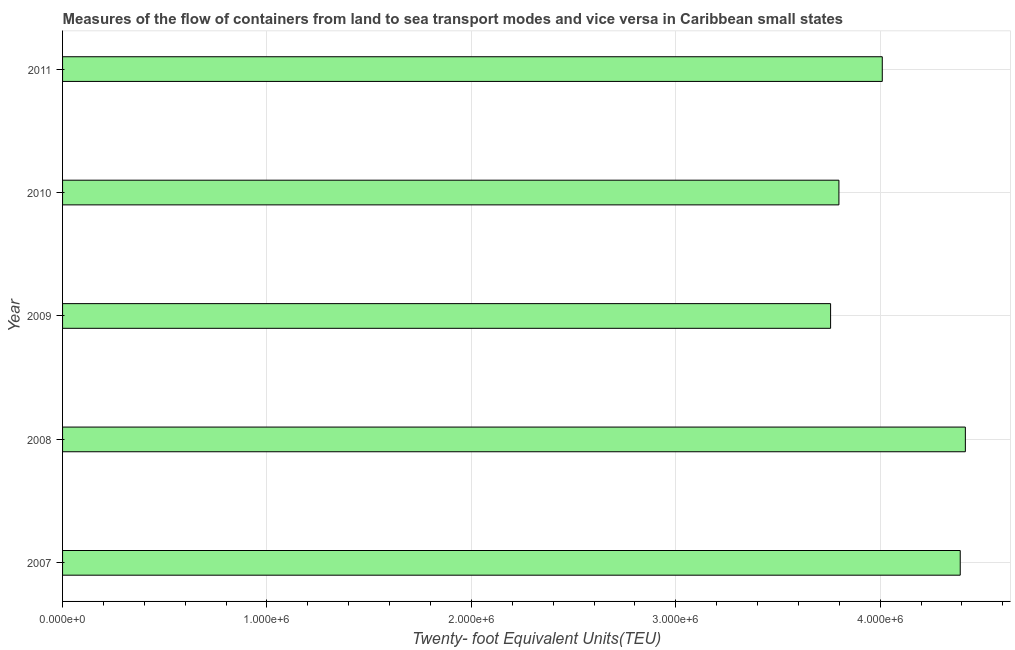Does the graph contain any zero values?
Your answer should be very brief. No. Does the graph contain grids?
Your response must be concise. Yes. What is the title of the graph?
Make the answer very short. Measures of the flow of containers from land to sea transport modes and vice versa in Caribbean small states. What is the label or title of the X-axis?
Give a very brief answer. Twenty- foot Equivalent Units(TEU). What is the container port traffic in 2011?
Offer a very short reply. 4.01e+06. Across all years, what is the maximum container port traffic?
Provide a succinct answer. 4.42e+06. Across all years, what is the minimum container port traffic?
Offer a very short reply. 3.76e+06. In which year was the container port traffic minimum?
Give a very brief answer. 2009. What is the sum of the container port traffic?
Keep it short and to the point. 2.04e+07. What is the difference between the container port traffic in 2007 and 2010?
Provide a short and direct response. 5.94e+05. What is the average container port traffic per year?
Make the answer very short. 4.07e+06. What is the median container port traffic?
Make the answer very short. 4.01e+06. What is the ratio of the container port traffic in 2007 to that in 2011?
Offer a terse response. 1.09. Is the container port traffic in 2010 less than that in 2011?
Your answer should be very brief. Yes. What is the difference between the highest and the second highest container port traffic?
Your answer should be compact. 2.50e+04. What is the difference between the highest and the lowest container port traffic?
Keep it short and to the point. 6.59e+05. How many bars are there?
Keep it short and to the point. 5. Are all the bars in the graph horizontal?
Your answer should be compact. Yes. How many years are there in the graph?
Provide a succinct answer. 5. What is the difference between two consecutive major ticks on the X-axis?
Your response must be concise. 1.00e+06. What is the Twenty- foot Equivalent Units(TEU) in 2007?
Keep it short and to the point. 4.39e+06. What is the Twenty- foot Equivalent Units(TEU) in 2008?
Ensure brevity in your answer.  4.42e+06. What is the Twenty- foot Equivalent Units(TEU) in 2009?
Provide a succinct answer. 3.76e+06. What is the Twenty- foot Equivalent Units(TEU) in 2010?
Offer a terse response. 3.80e+06. What is the Twenty- foot Equivalent Units(TEU) in 2011?
Offer a terse response. 4.01e+06. What is the difference between the Twenty- foot Equivalent Units(TEU) in 2007 and 2008?
Ensure brevity in your answer.  -2.50e+04. What is the difference between the Twenty- foot Equivalent Units(TEU) in 2007 and 2009?
Your answer should be compact. 6.34e+05. What is the difference between the Twenty- foot Equivalent Units(TEU) in 2007 and 2010?
Ensure brevity in your answer.  5.94e+05. What is the difference between the Twenty- foot Equivalent Units(TEU) in 2007 and 2011?
Your answer should be very brief. 3.81e+05. What is the difference between the Twenty- foot Equivalent Units(TEU) in 2008 and 2009?
Provide a succinct answer. 6.59e+05. What is the difference between the Twenty- foot Equivalent Units(TEU) in 2008 and 2010?
Give a very brief answer. 6.19e+05. What is the difference between the Twenty- foot Equivalent Units(TEU) in 2008 and 2011?
Provide a succinct answer. 4.06e+05. What is the difference between the Twenty- foot Equivalent Units(TEU) in 2009 and 2010?
Your response must be concise. -4.07e+04. What is the difference between the Twenty- foot Equivalent Units(TEU) in 2009 and 2011?
Your response must be concise. -2.53e+05. What is the difference between the Twenty- foot Equivalent Units(TEU) in 2010 and 2011?
Your answer should be very brief. -2.12e+05. What is the ratio of the Twenty- foot Equivalent Units(TEU) in 2007 to that in 2009?
Your response must be concise. 1.17. What is the ratio of the Twenty- foot Equivalent Units(TEU) in 2007 to that in 2010?
Ensure brevity in your answer.  1.16. What is the ratio of the Twenty- foot Equivalent Units(TEU) in 2007 to that in 2011?
Ensure brevity in your answer.  1.09. What is the ratio of the Twenty- foot Equivalent Units(TEU) in 2008 to that in 2009?
Provide a succinct answer. 1.18. What is the ratio of the Twenty- foot Equivalent Units(TEU) in 2008 to that in 2010?
Your answer should be very brief. 1.16. What is the ratio of the Twenty- foot Equivalent Units(TEU) in 2008 to that in 2011?
Your answer should be compact. 1.1. What is the ratio of the Twenty- foot Equivalent Units(TEU) in 2009 to that in 2011?
Offer a very short reply. 0.94. What is the ratio of the Twenty- foot Equivalent Units(TEU) in 2010 to that in 2011?
Offer a very short reply. 0.95. 